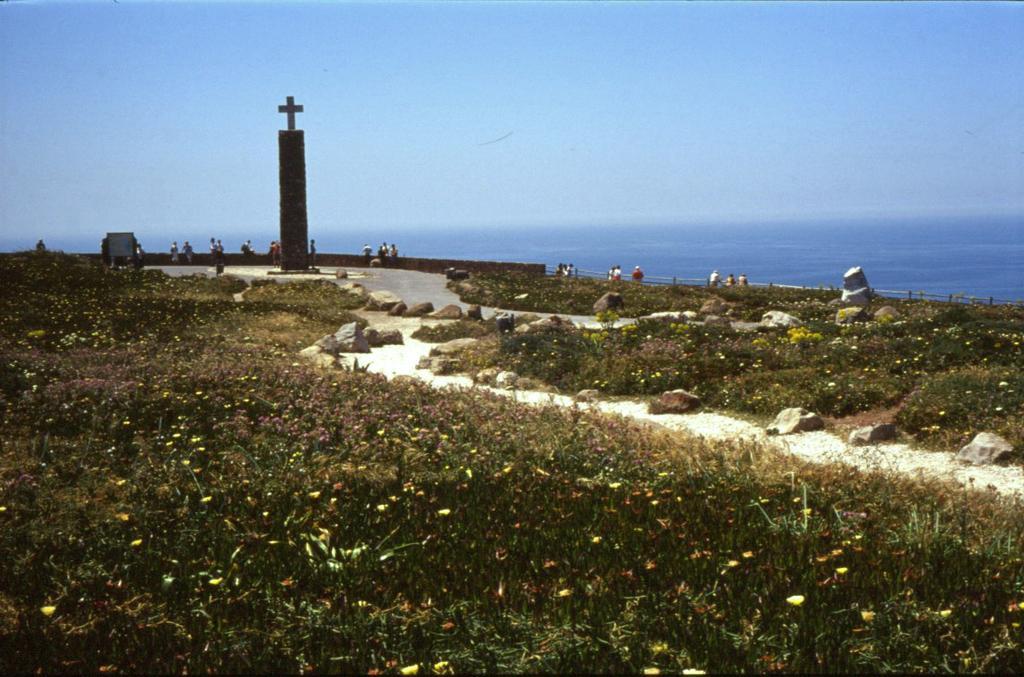Describe this image in one or two sentences. The picture is clicked on a sea beach. This is a pillar with cross mark. There are few people sitting on the boundary. On the foreground there are plants, grasses on the ground. This is the path. On the path there are stones. In the background there is water body. The sky is clear. 